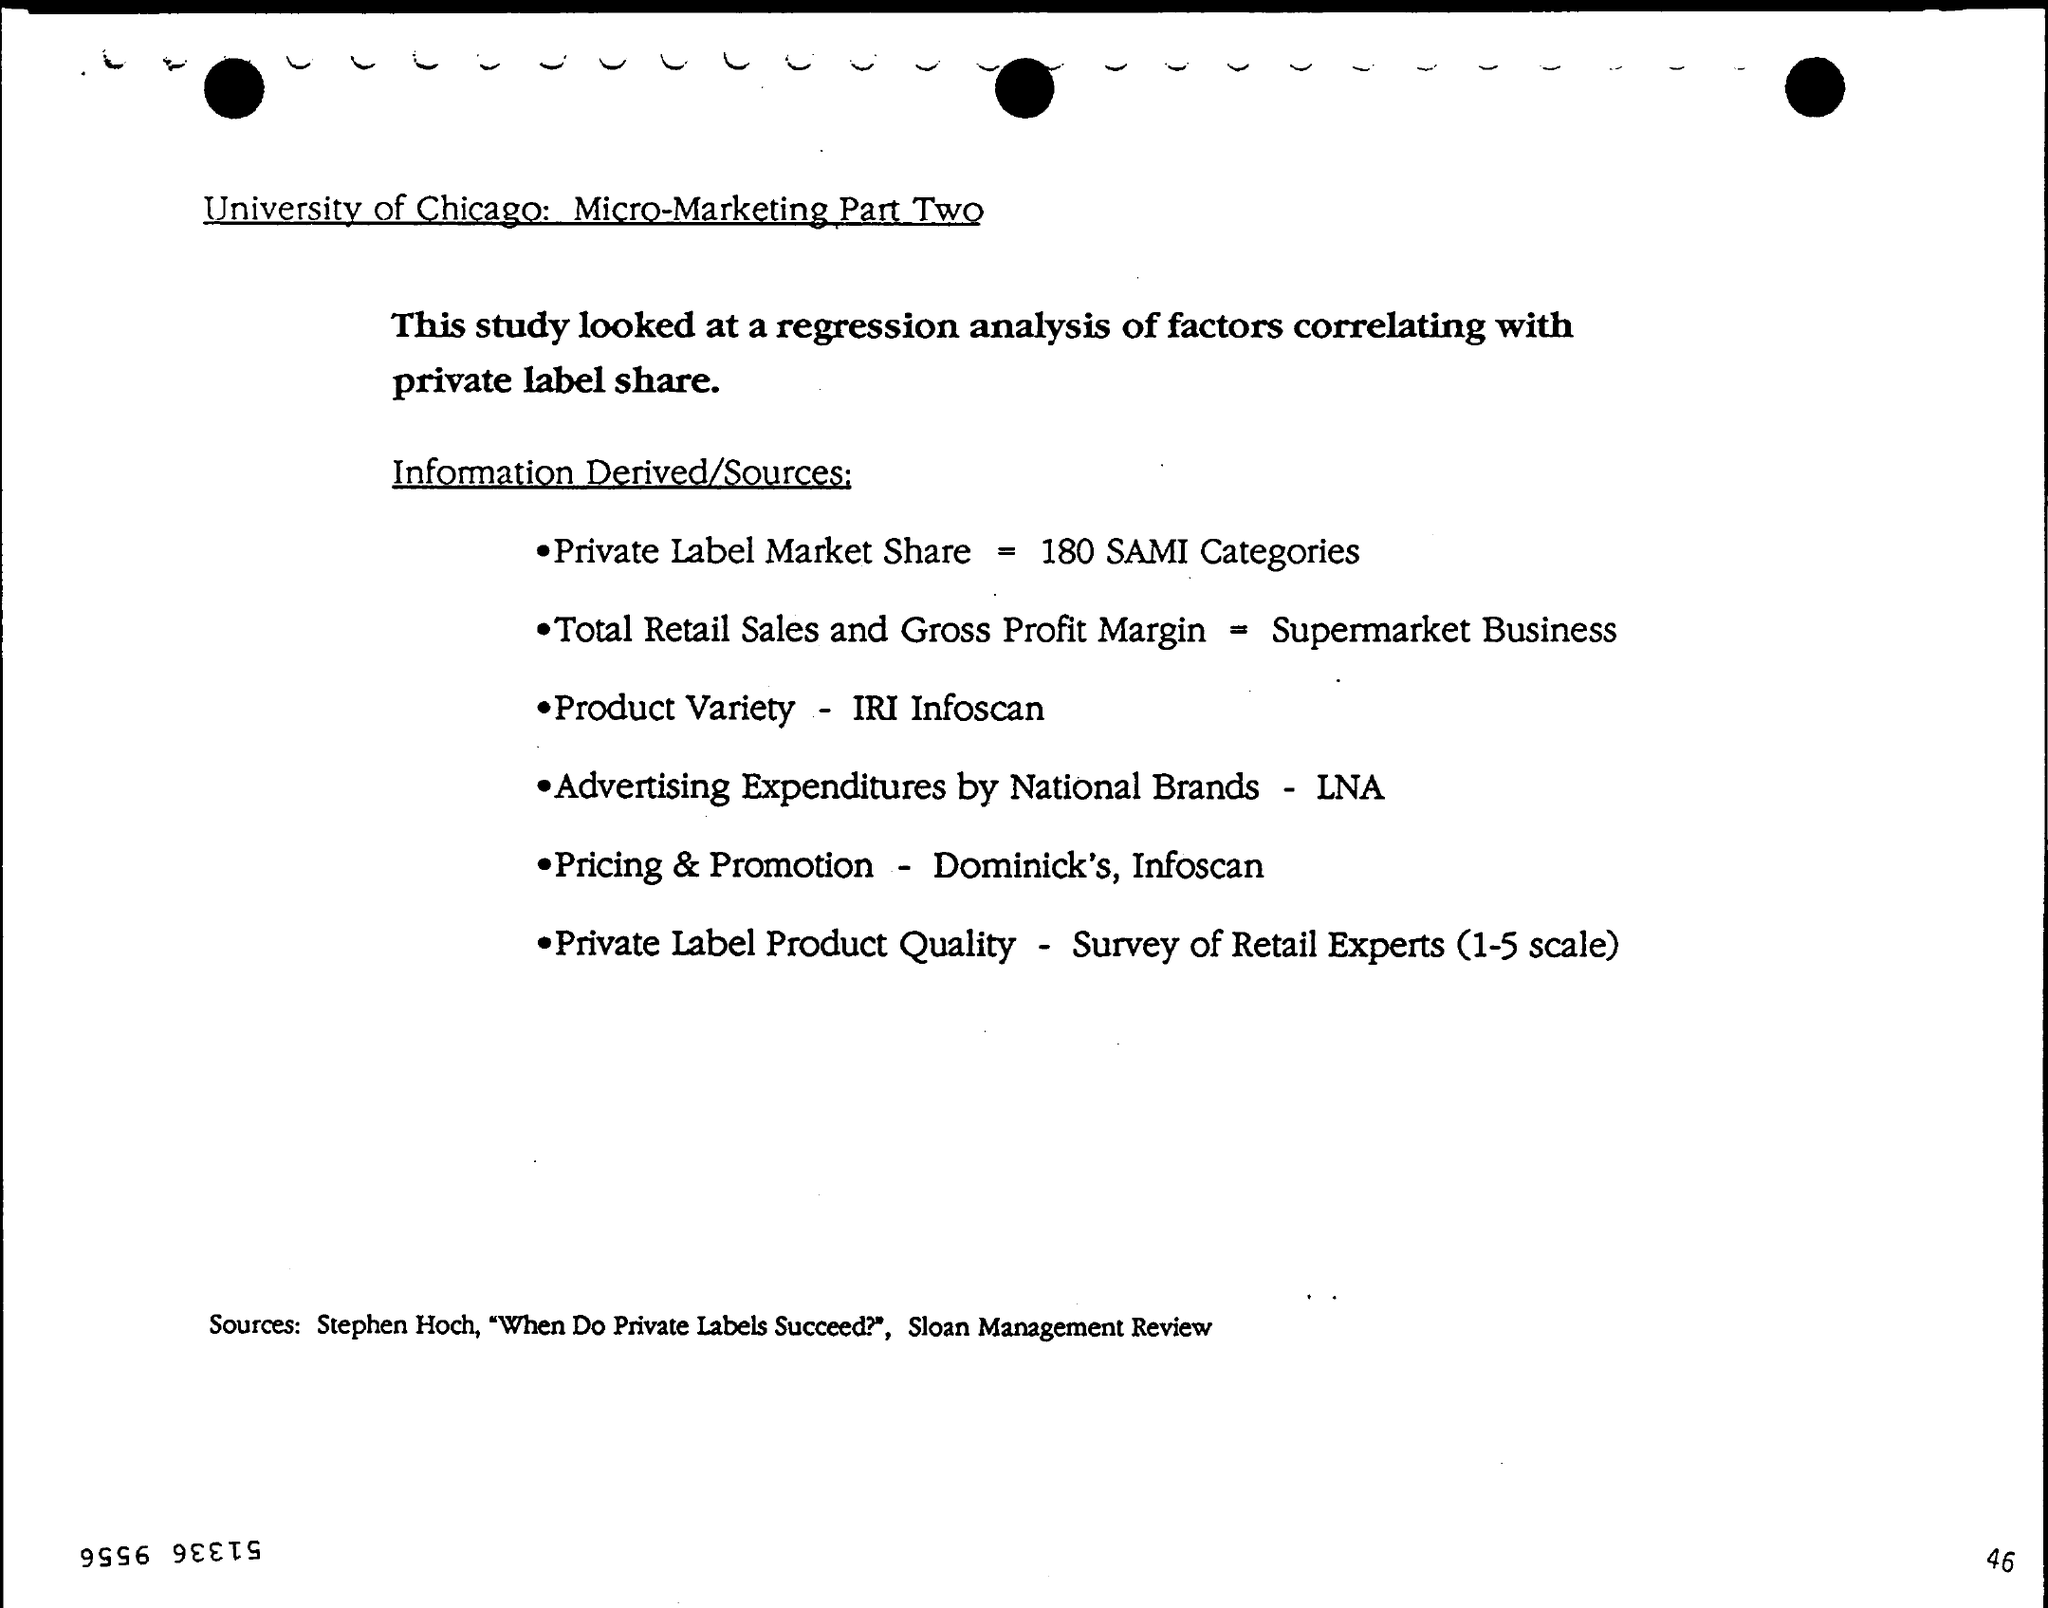What is the Private Label Market Share?
Provide a succinct answer. 180 SAMI Categories. What is the Total Retail Sales and Gross Profit Margin?
Offer a very short reply. Supermarket Business. What is the Product Variety?
Give a very brief answer. IRI Infoscan. What is the Advertising Expenditures by National Brands?
Give a very brief answer. LNA. What is the Pricing & Promotion?
Give a very brief answer. Dominick's, Infoscan. What is the Private Label Product Quality?
Make the answer very short. Survey of Retail Experts (1-5 scale). 